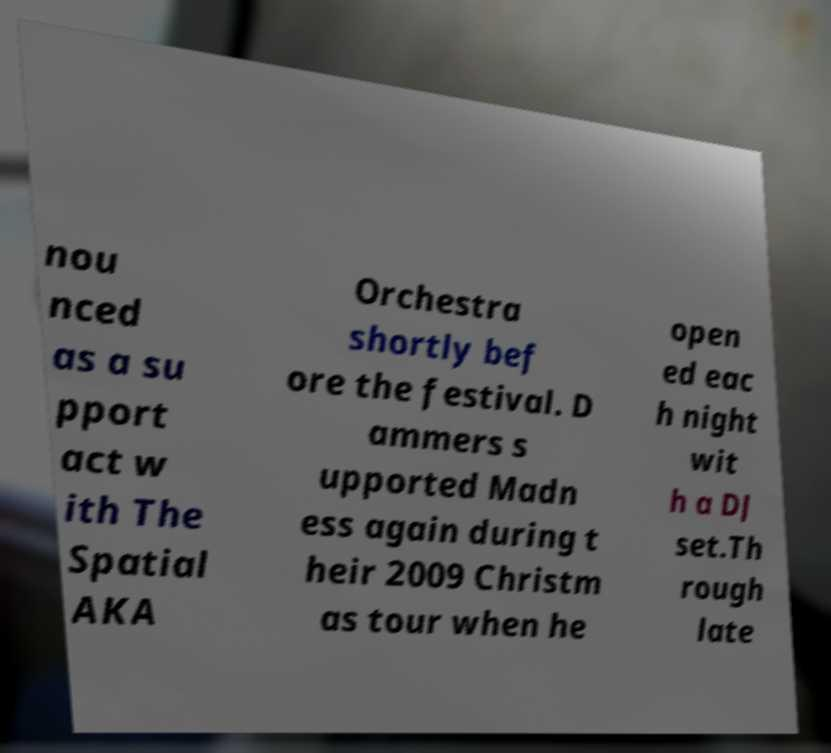Could you extract and type out the text from this image? nou nced as a su pport act w ith The Spatial AKA Orchestra shortly bef ore the festival. D ammers s upported Madn ess again during t heir 2009 Christm as tour when he open ed eac h night wit h a DJ set.Th rough late 